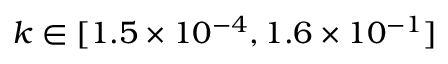<formula> <loc_0><loc_0><loc_500><loc_500>k \in [ 1 . 5 \times 1 0 ^ { - 4 } , 1 . 6 \times 1 0 ^ { - 1 } ]</formula> 